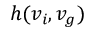Convert formula to latex. <formula><loc_0><loc_0><loc_500><loc_500>h ( v _ { i } , v _ { g } )</formula> 